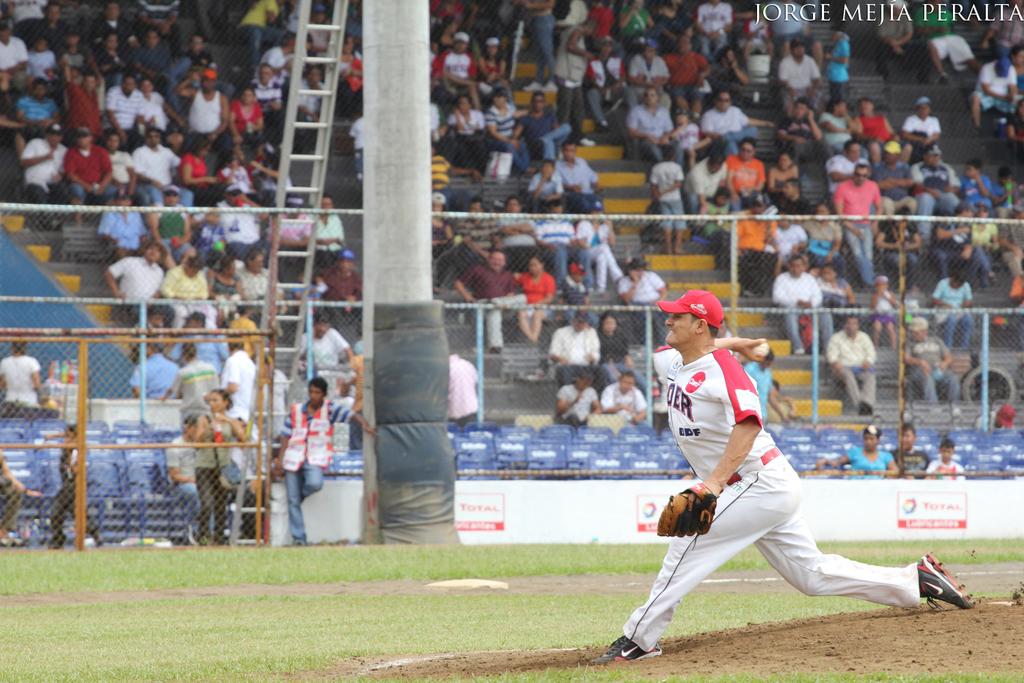What three words is in the top right corner?
Your answer should be very brief. Jorge mejia peralta. 